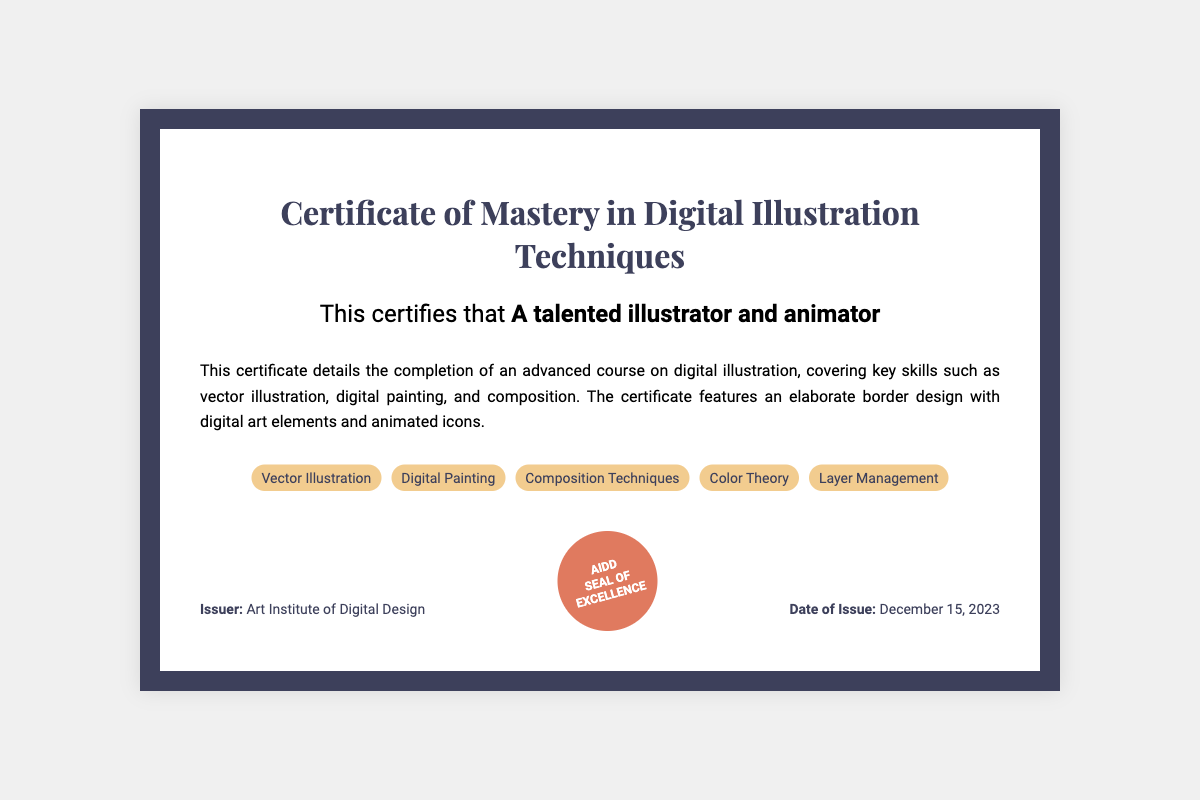What is the title of the certificate? The title indicates the specific achievement recognized by the document, which is "Certificate of Mastery in Digital Illustration Techniques."
Answer: Certificate of Mastery in Digital Illustration Techniques Who received the certificate? The recipient's name is presented in bold, indicating the individual recognized for completing the course.
Answer: A talented illustrator and animator What skills are covered in this advanced course? The skills listed provide insight into what was learned and includes multiple areas of expertise.
Answer: Vector Illustration, Digital Painting, Composition Techniques, Color Theory, Layer Management Who is the issuer of the certificate? The issuer is the organization that awards the certificate, providing credibility to the accomplishment.
Answer: Art Institute of Digital Design What is the date of issue for the certificate? The date of issue shows when the certification was granted, marking the completion of the course.
Answer: December 15, 2023 What type of design elements are featured on the certificate? The description highlights the artistic components used in the certificate's layout.
Answer: Digital art elements and animated icons What is the purpose of the holographic seal? The seal represents a formal verification of authenticity and excellence associated with the certificate.
Answer: Seal of Excellence What does the certificate's elaborate border design signify? The border design is a reflection of creativity, connecting to the artistic achievements recognized in the certificate.
Answer: Creativity and artistry 